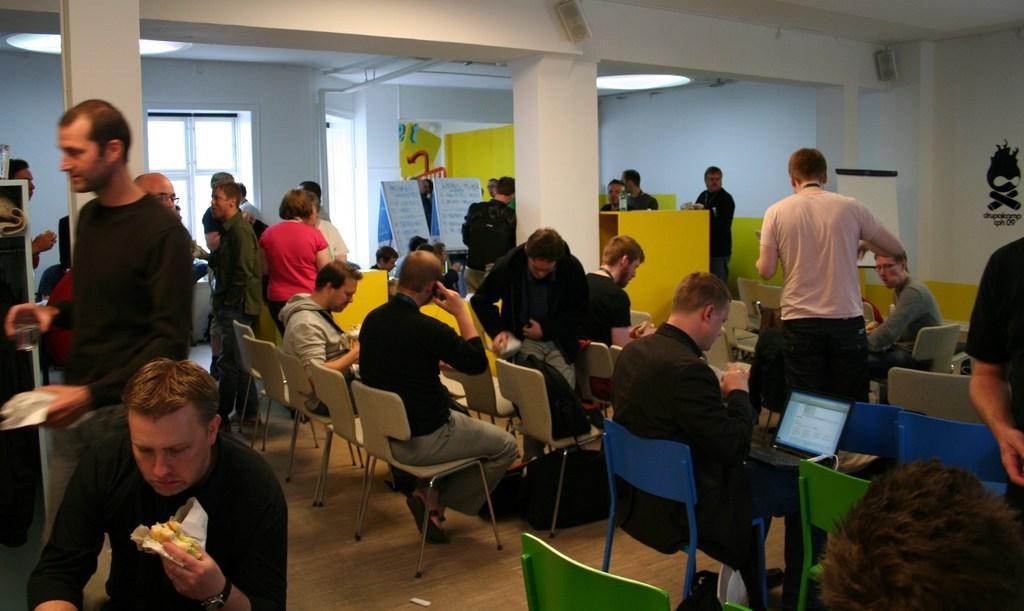Can you describe this image briefly? There are many people sitting and standing in this room. A person in the front is holding a food item and eating. He is wearing a watch. There are many chairs. Another person is holding a laptop and working. In the background there is a wall. There are pillars, also there are boards, windows and doors in the background. 